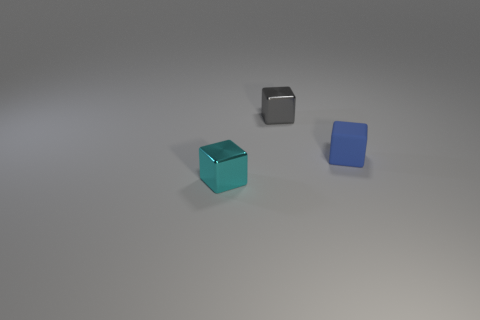Are there any other things that have the same material as the blue block?
Offer a very short reply. No. What number of cylinders are tiny blue rubber objects or gray metallic objects?
Offer a very short reply. 0. Are there any other tiny gray rubber objects of the same shape as the small gray object?
Offer a very short reply. No. How many things are either small blue rubber cubes or cyan metallic things?
Give a very brief answer. 2. Does the metallic cube that is behind the cyan metallic cube have the same size as the block right of the gray metallic object?
Provide a short and direct response. Yes. What number of other objects are the same material as the cyan block?
Keep it short and to the point. 1. Is the number of tiny cyan cubes on the left side of the small cyan metallic object greater than the number of small gray metallic cubes that are in front of the blue rubber thing?
Ensure brevity in your answer.  No. What material is the block that is left of the tiny gray metal block?
Make the answer very short. Metal. Is the gray object the same shape as the small cyan shiny object?
Make the answer very short. Yes. Is there any other thing that is the same color as the matte object?
Provide a short and direct response. No. 